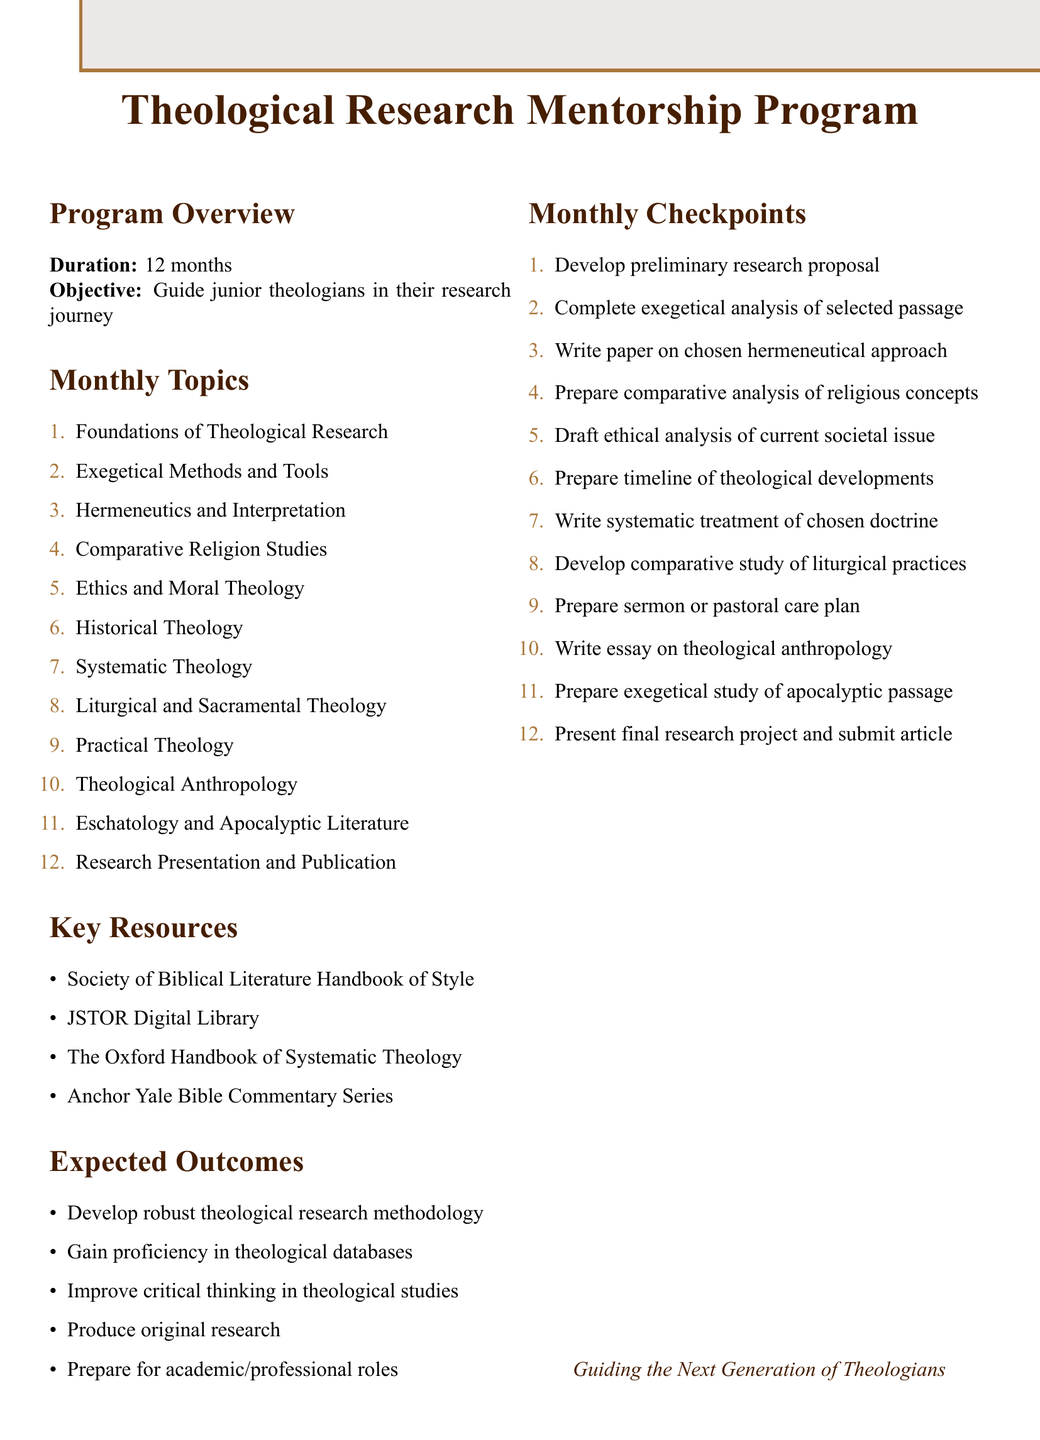What is the title of the program? The title of the program is stated in the document's introduction.
Answer: Theological Research Mentorship Program How long is the program's duration? The duration is specified at the beginning of the document.
Answer: 12 months What is the main focus of the first month's topic? The first month covers the foundational aspects essential for theological research.
Answer: Foundations of Theological Research What is the expected outcome related to critical thinking? The expected outcomes section mentions improvement in specific skills, including critical thinking.
Answer: Improve critical thinking in theological studies Which resources include access to theological journals? The resources section lists various tools, including digital libraries that provide access to academic content.
Answer: JSTOR What is the checkpoint for the fifth month? Each month's checkpoint indicates the specific task to be completed, which can be found in the document's structure.
Answer: Draft an ethical analysis of a current societal issue Name one major theologian analyzed in month three. The document refers to influential theologians as part of the activities for month three, as an example.
Answer: Karl Barth What is the checkpoint activity for month twelve? The final month’s checkpoint activity is outlined among the listed checkpoints related to research presentation.
Answer: Present final research project and submit article How many topics are covered throughout the program? The total number of topics is indicated in the monthly topics section of the document.
Answer: 12 